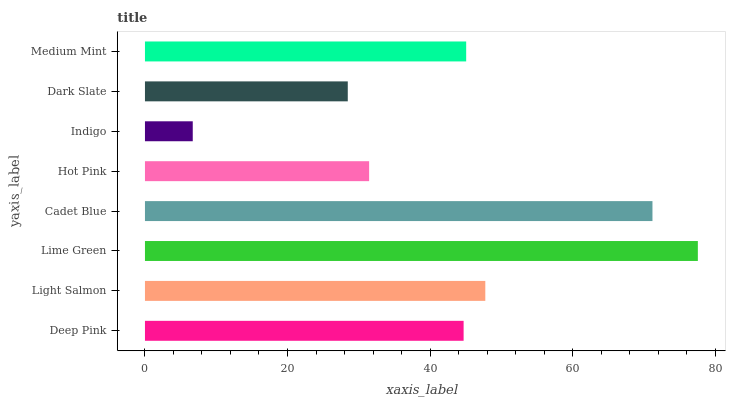Is Indigo the minimum?
Answer yes or no. Yes. Is Lime Green the maximum?
Answer yes or no. Yes. Is Light Salmon the minimum?
Answer yes or no. No. Is Light Salmon the maximum?
Answer yes or no. No. Is Light Salmon greater than Deep Pink?
Answer yes or no. Yes. Is Deep Pink less than Light Salmon?
Answer yes or no. Yes. Is Deep Pink greater than Light Salmon?
Answer yes or no. No. Is Light Salmon less than Deep Pink?
Answer yes or no. No. Is Medium Mint the high median?
Answer yes or no. Yes. Is Deep Pink the low median?
Answer yes or no. Yes. Is Deep Pink the high median?
Answer yes or no. No. Is Indigo the low median?
Answer yes or no. No. 